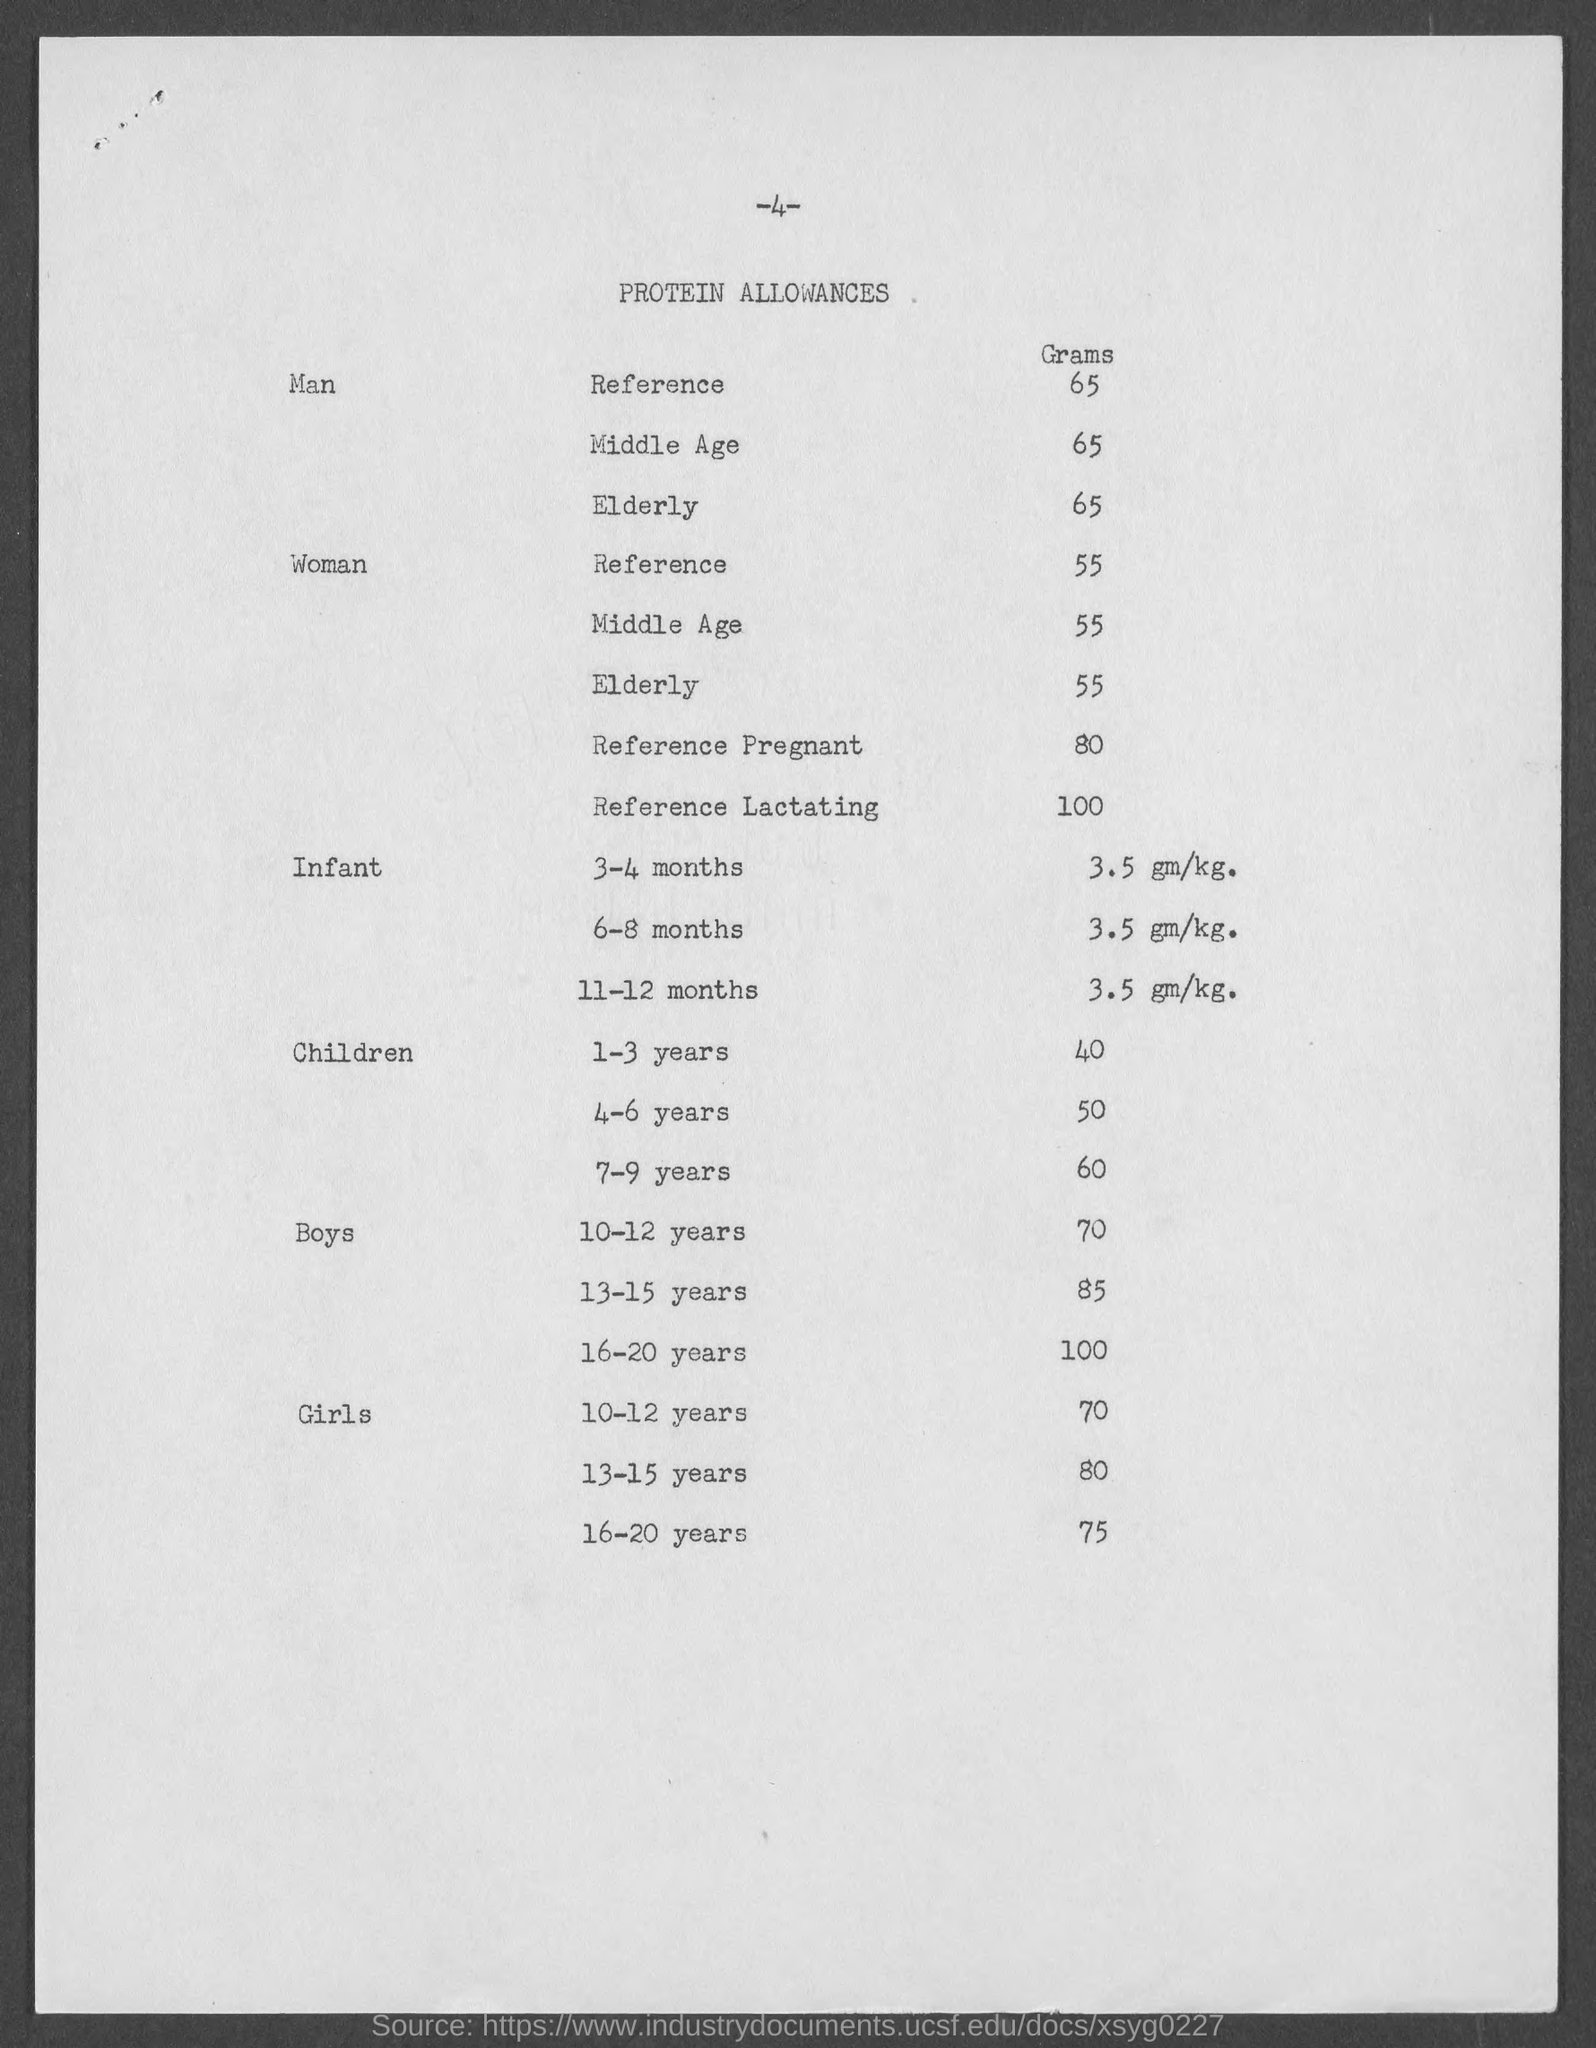Indicate a few pertinent items in this graphic. The page number at the top of the page is -4-. The heading of the page is 'Protein Allowances'. 